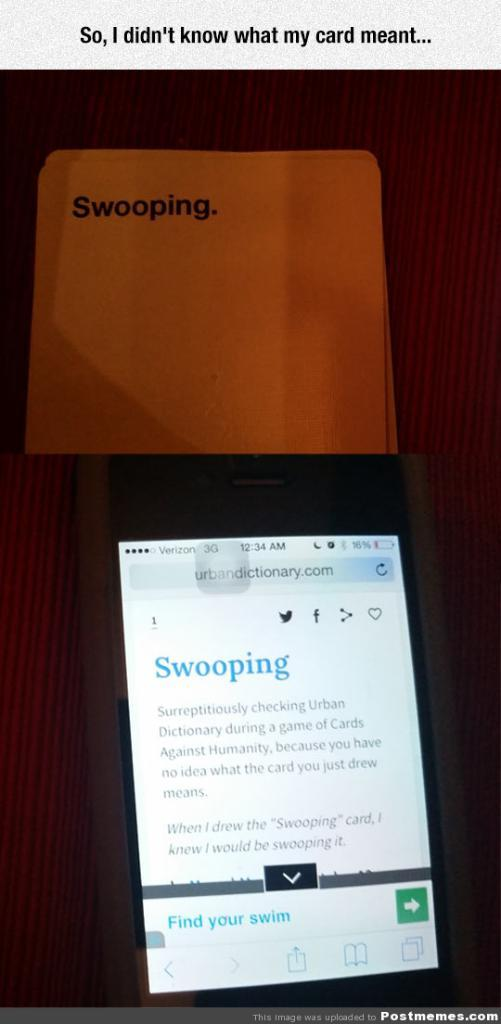<image>
Relay a brief, clear account of the picture shown. Phone under a white card with the word SWOOPING on it. 